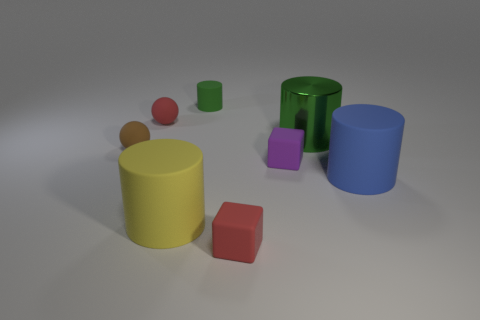There is a large matte object that is on the right side of the big green shiny cylinder; what is its shape?
Offer a terse response. Cylinder. Is the number of tiny matte spheres that are on the right side of the tiny red matte sphere less than the number of red objects behind the metallic cylinder?
Offer a very short reply. Yes. Do the small block left of the small purple rubber thing and the green cylinder that is in front of the red matte sphere have the same material?
Your answer should be very brief. No. There is a small brown object; what shape is it?
Provide a succinct answer. Sphere. Is the number of tiny red objects in front of the brown matte sphere greater than the number of small purple objects that are behind the small purple rubber cube?
Keep it short and to the point. Yes. Is the shape of the small red matte object that is to the left of the green matte object the same as the brown thing to the left of the tiny purple cube?
Your answer should be very brief. Yes. What number of other objects are the same size as the purple object?
Provide a short and direct response. 4. What size is the purple rubber object?
Your answer should be compact. Small. Is the material of the red object left of the small green thing the same as the big green thing?
Your answer should be very brief. No. There is another small thing that is the same shape as the purple thing; what is its color?
Your answer should be compact. Red. 